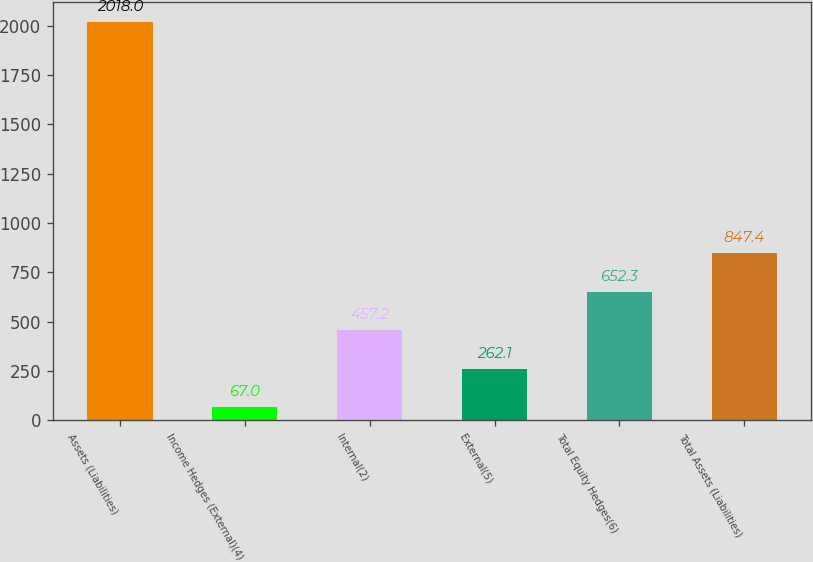Convert chart to OTSL. <chart><loc_0><loc_0><loc_500><loc_500><bar_chart><fcel>Assets (Liabilities)<fcel>Income Hedges (External)(4)<fcel>Internal(2)<fcel>External(5)<fcel>Total Equity Hedges(6)<fcel>Total Assets (Liabilities)<nl><fcel>2018<fcel>67<fcel>457.2<fcel>262.1<fcel>652.3<fcel>847.4<nl></chart> 